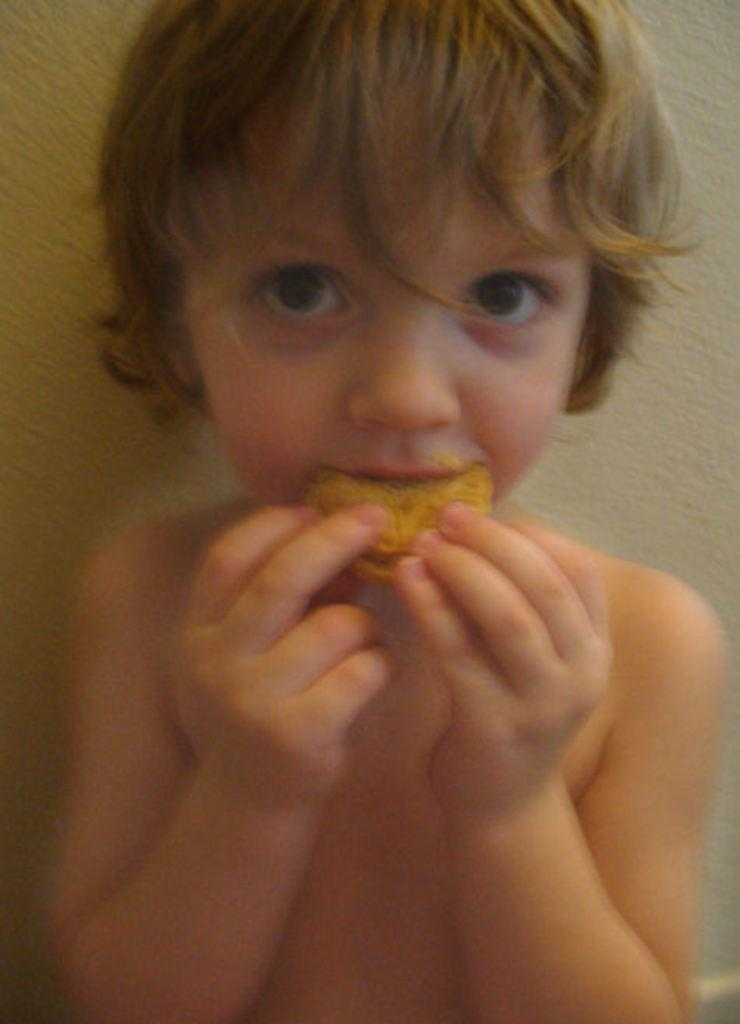What is the main subject of the image? The main subject of the image is a kid. What is the kid doing in the image? The kid is holding food and eating it. What can be seen in the background of the image? There is a wall in the background of the image. How many family members are visible in the image? There is no family member visible in the image besides the kid. What color is the kid's eye in the image? The color of the kid's eye cannot be determined from the image. 